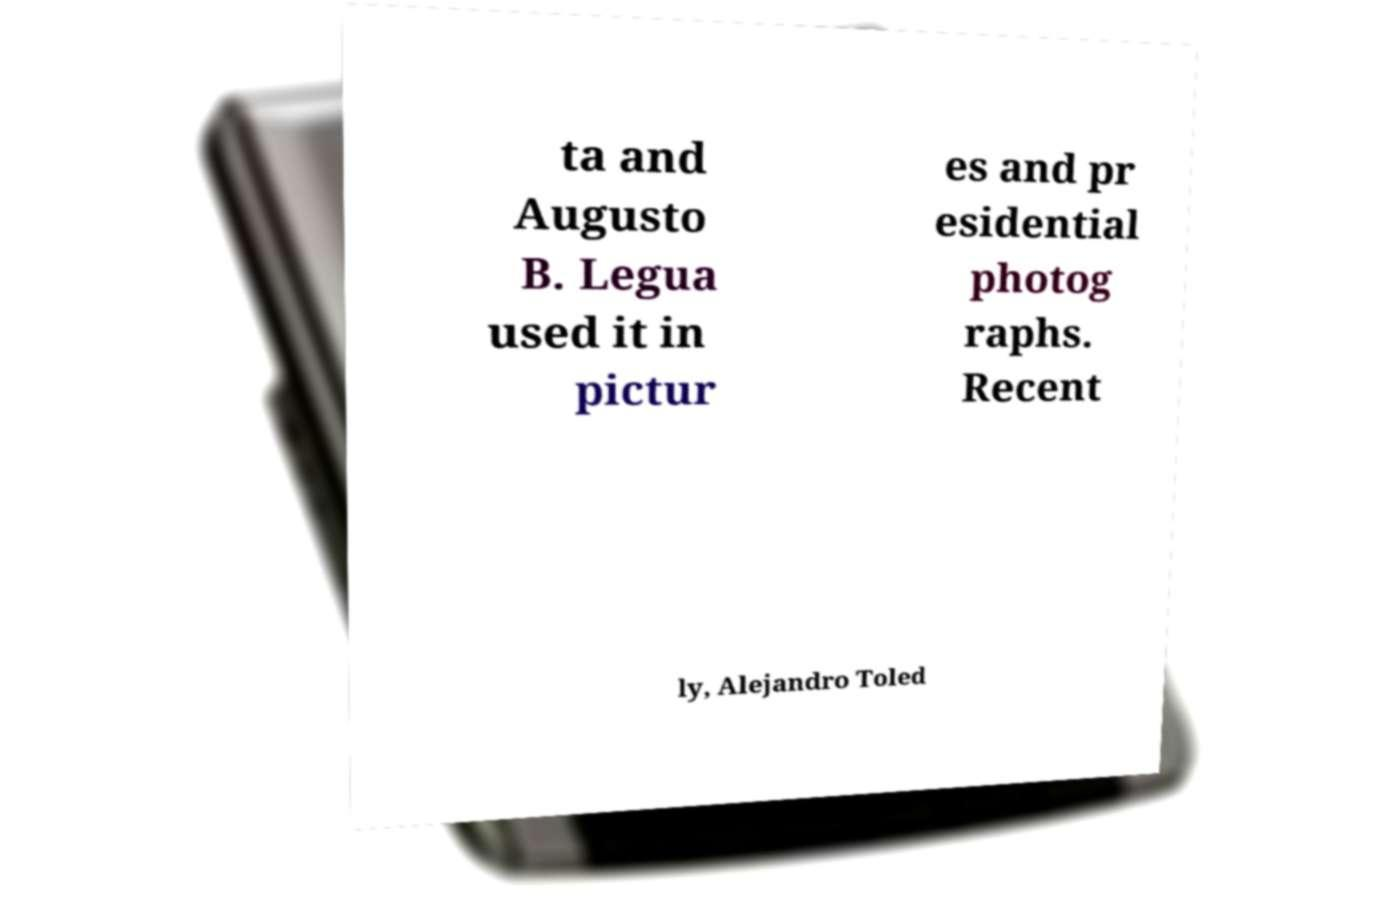Can you read and provide the text displayed in the image?This photo seems to have some interesting text. Can you extract and type it out for me? ta and Augusto B. Legua used it in pictur es and pr esidential photog raphs. Recent ly, Alejandro Toled 